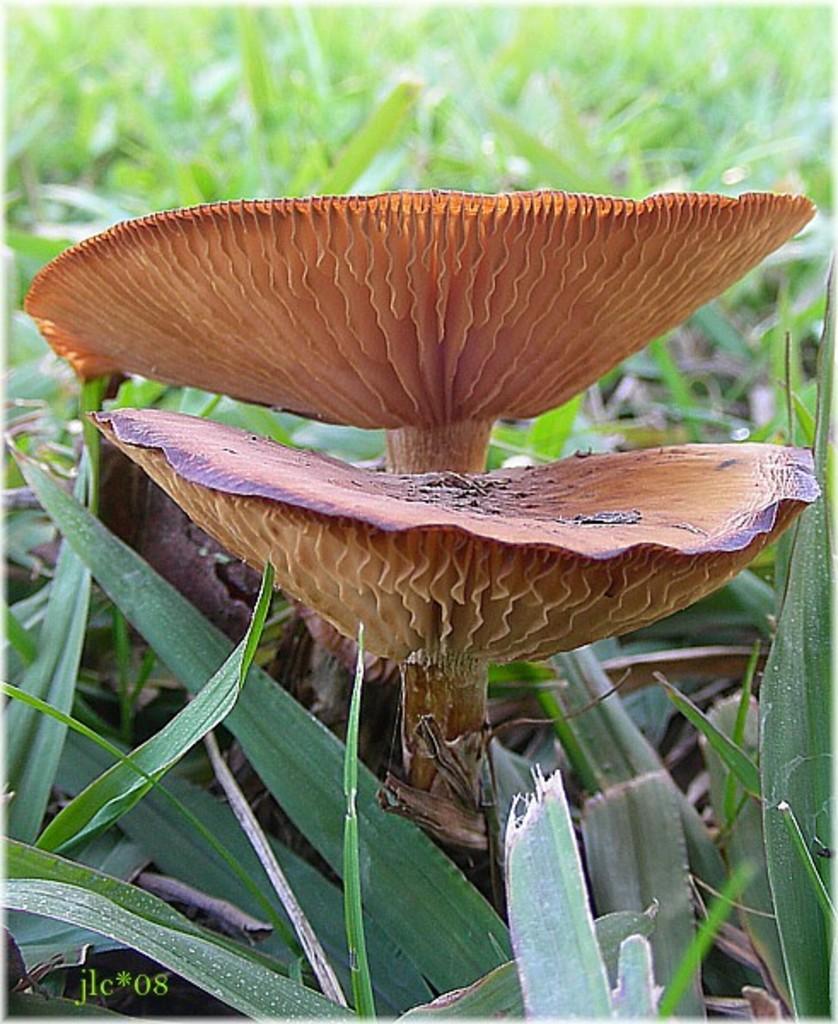Please provide a concise description of this image. In this image we can see a grassy land. There are two mushrooms in the image. 